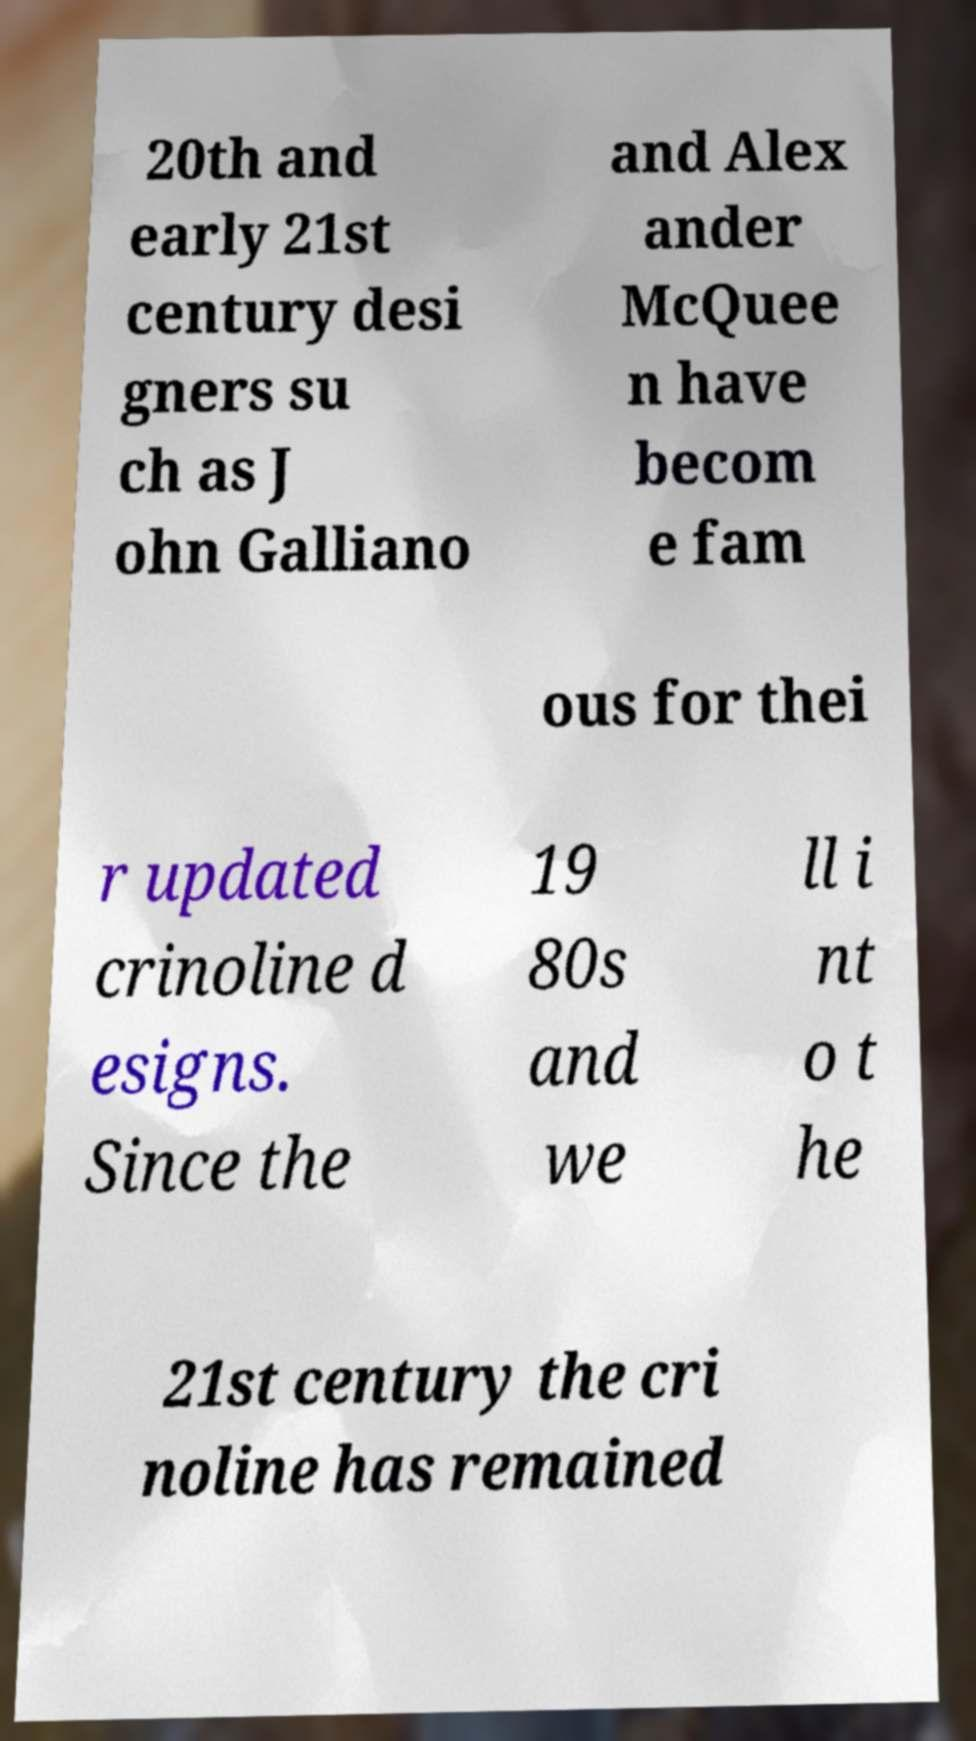I need the written content from this picture converted into text. Can you do that? 20th and early 21st century desi gners su ch as J ohn Galliano and Alex ander McQuee n have becom e fam ous for thei r updated crinoline d esigns. Since the 19 80s and we ll i nt o t he 21st century the cri noline has remained 